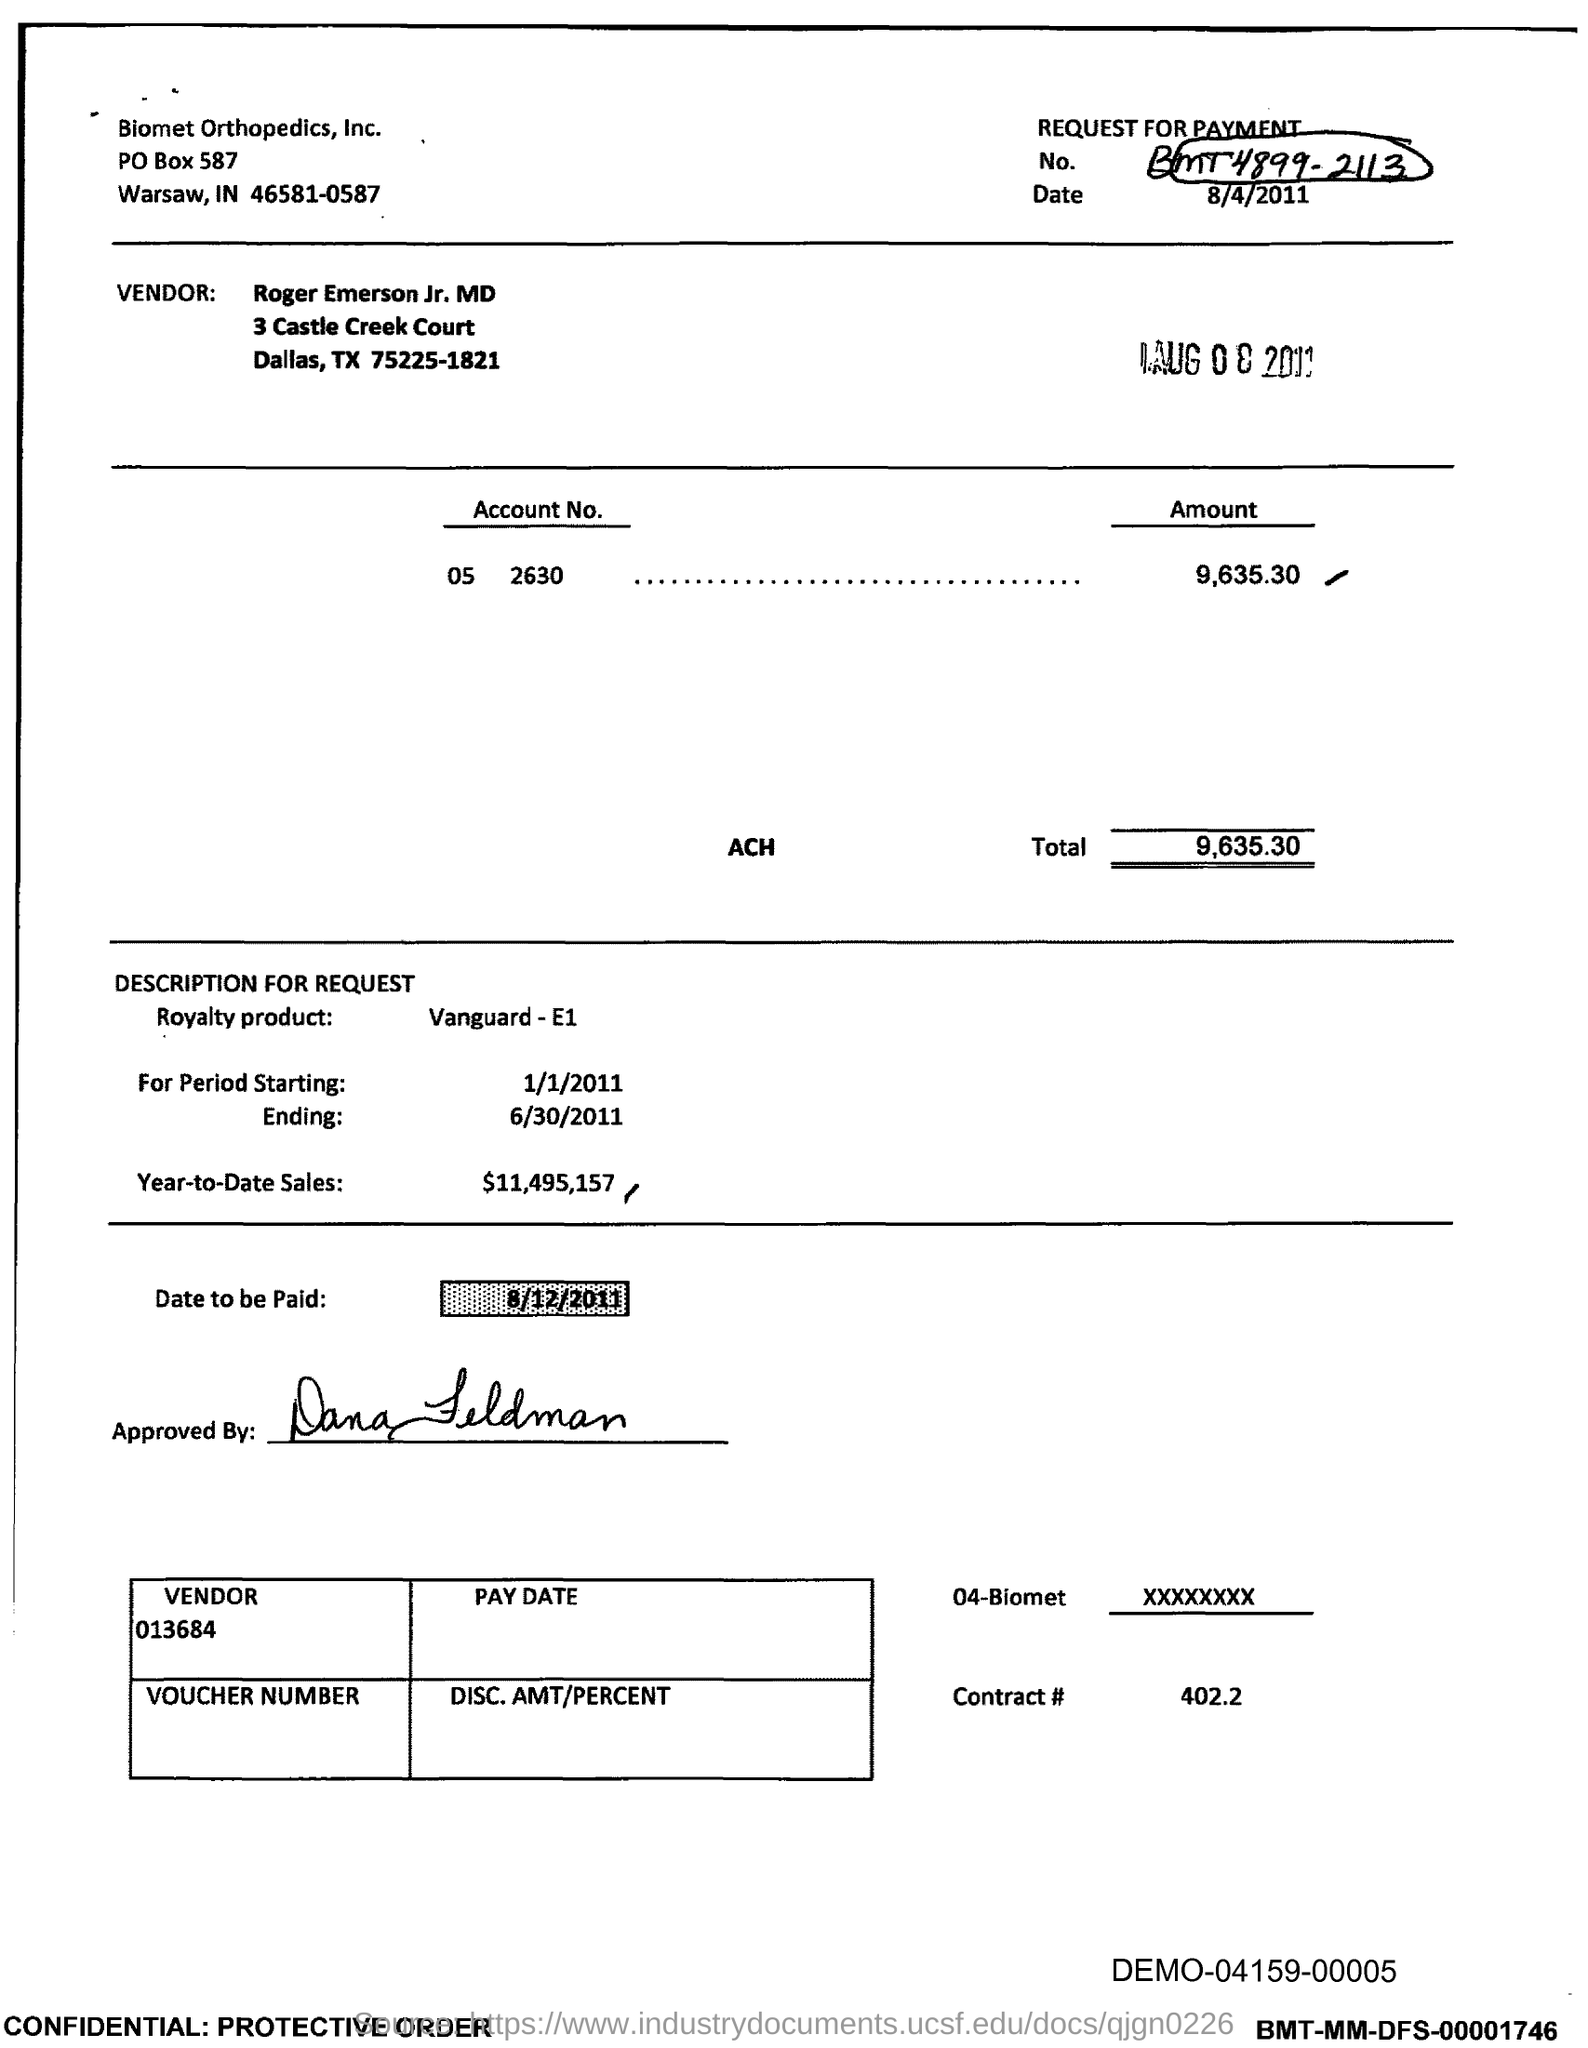What is the request for payment No. given in the document?
Provide a short and direct response. BMT4899-2113. What is the vendor name given in the document?
Provide a succinct answer. Roger Emerson Jr. MD. What is the Account No. given in the document?
Your response must be concise. 05 2630. What is the total amount to be paid given in the document?
Your response must be concise. 9,635.30. What is the royalty product given in the document?
Make the answer very short. Vanguard - E1. What is the Year-to-Date Sales of the royalty product?
Offer a terse response. $11,495,157. What is the vendor number given in the document?
Offer a terse response. 013684. What is the Contract No. given in the document?
Offer a terse response. 402.2. What is the royalty period starting date mentioned in the document?
Provide a short and direct response. 1/1/2011. 